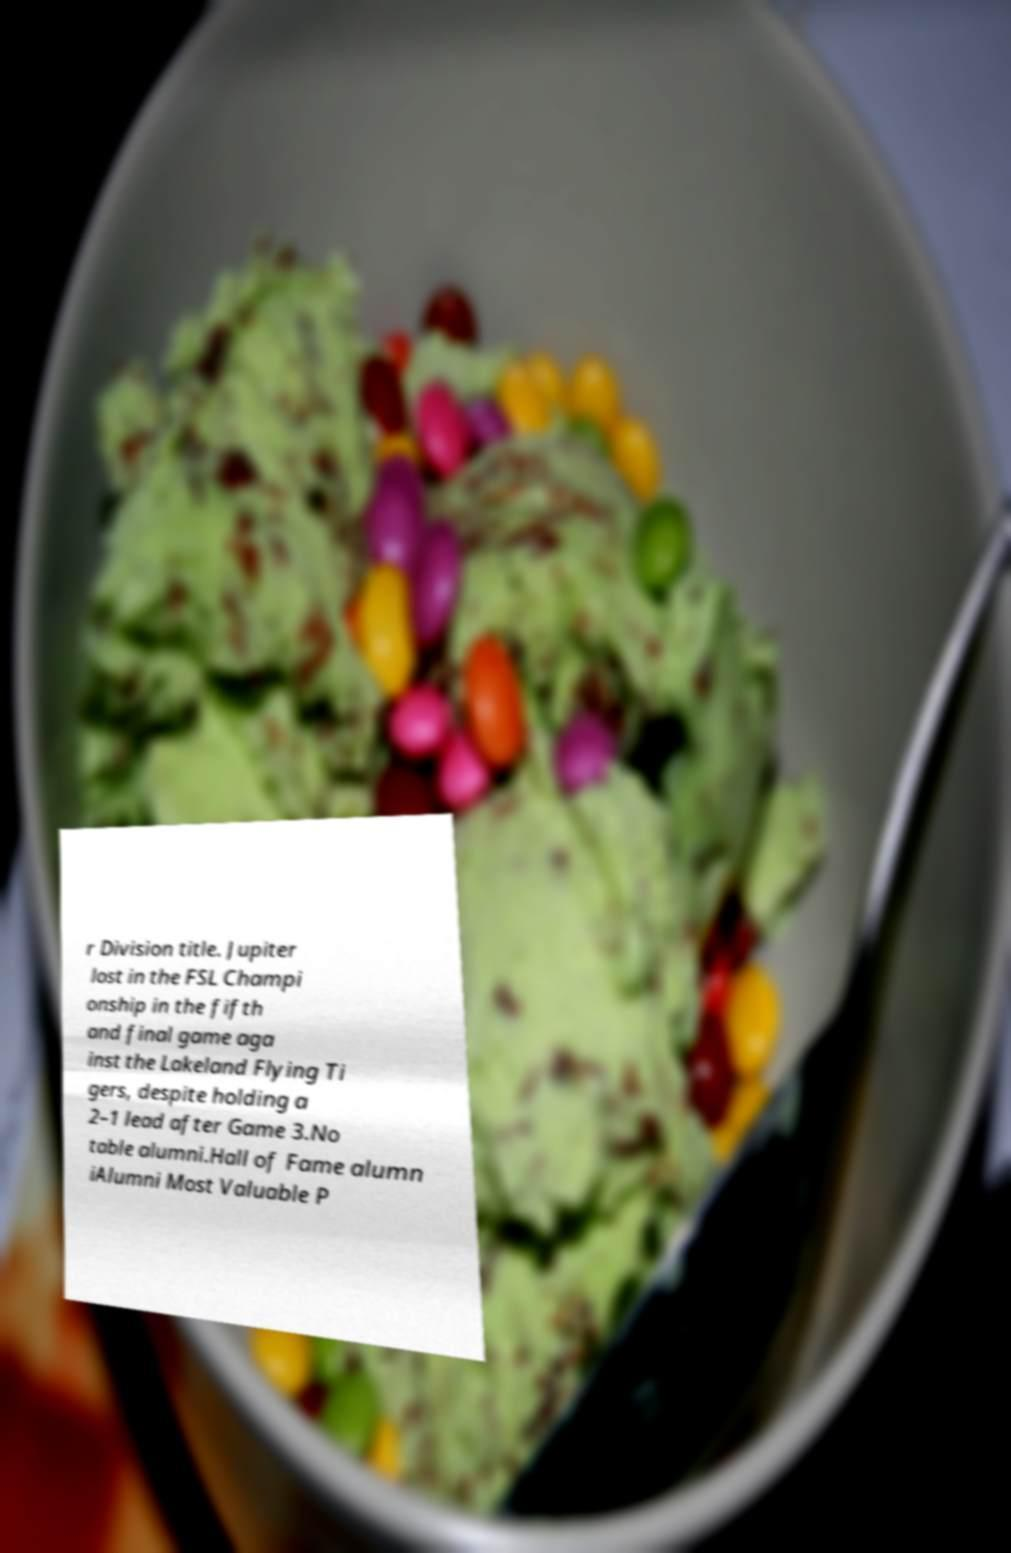Could you extract and type out the text from this image? r Division title. Jupiter lost in the FSL Champi onship in the fifth and final game aga inst the Lakeland Flying Ti gers, despite holding a 2–1 lead after Game 3.No table alumni.Hall of Fame alumn iAlumni Most Valuable P 